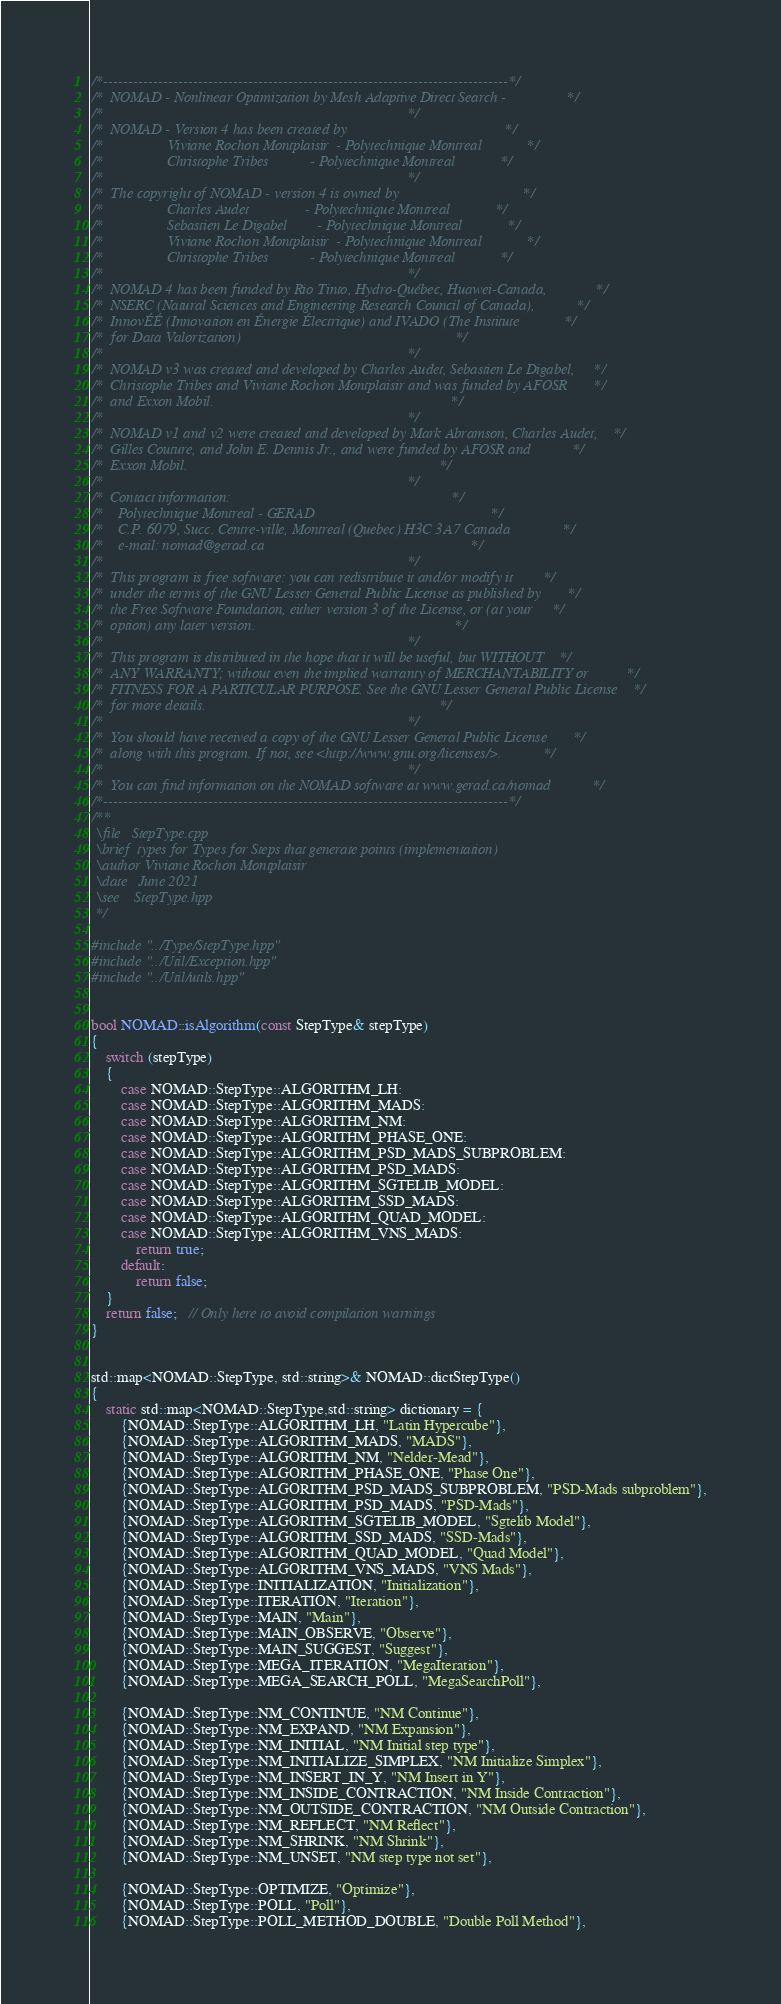Convert code to text. <code><loc_0><loc_0><loc_500><loc_500><_C++_>/*---------------------------------------------------------------------------------*/
/*  NOMAD - Nonlinear Optimization by Mesh Adaptive Direct Search -                */
/*                                                                                 */
/*  NOMAD - Version 4 has been created by                                          */
/*                 Viviane Rochon Montplaisir  - Polytechnique Montreal            */
/*                 Christophe Tribes           - Polytechnique Montreal            */
/*                                                                                 */
/*  The copyright of NOMAD - version 4 is owned by                                 */
/*                 Charles Audet               - Polytechnique Montreal            */
/*                 Sebastien Le Digabel        - Polytechnique Montreal            */
/*                 Viviane Rochon Montplaisir  - Polytechnique Montreal            */
/*                 Christophe Tribes           - Polytechnique Montreal            */
/*                                                                                 */
/*  NOMAD 4 has been funded by Rio Tinto, Hydro-Québec, Huawei-Canada,             */
/*  NSERC (Natural Sciences and Engineering Research Council of Canada),           */
/*  InnovÉÉ (Innovation en Énergie Électrique) and IVADO (The Institute            */
/*  for Data Valorization)                                                         */
/*                                                                                 */
/*  NOMAD v3 was created and developed by Charles Audet, Sebastien Le Digabel,     */
/*  Christophe Tribes and Viviane Rochon Montplaisir and was funded by AFOSR       */
/*  and Exxon Mobil.                                                               */
/*                                                                                 */
/*  NOMAD v1 and v2 were created and developed by Mark Abramson, Charles Audet,    */
/*  Gilles Couture, and John E. Dennis Jr., and were funded by AFOSR and           */
/*  Exxon Mobil.                                                                   */
/*                                                                                 */
/*  Contact information:                                                           */
/*    Polytechnique Montreal - GERAD                                               */
/*    C.P. 6079, Succ. Centre-ville, Montreal (Quebec) H3C 3A7 Canada              */
/*    e-mail: nomad@gerad.ca                                                       */
/*                                                                                 */
/*  This program is free software: you can redistribute it and/or modify it        */
/*  under the terms of the GNU Lesser General Public License as published by       */
/*  the Free Software Foundation, either version 3 of the License, or (at your     */
/*  option) any later version.                                                     */
/*                                                                                 */
/*  This program is distributed in the hope that it will be useful, but WITHOUT    */
/*  ANY WARRANTY; without even the implied warranty of MERCHANTABILITY or          */
/*  FITNESS FOR A PARTICULAR PURPOSE. See the GNU Lesser General Public License    */
/*  for more details.                                                              */
/*                                                                                 */
/*  You should have received a copy of the GNU Lesser General Public License       */
/*  along with this program. If not, see <http://www.gnu.org/licenses/>.           */
/*                                                                                 */
/*  You can find information on the NOMAD software at www.gerad.ca/nomad           */
/*---------------------------------------------------------------------------------*/
/**
 \file   StepType.cpp
 \brief  types for Types for Steps that generate points (implementation)
 \author Viviane Rochon Montplaisir
 \date   June 2021
 \see    StepType.hpp
 */

#include "../Type/StepType.hpp"
#include "../Util/Exception.hpp"
#include "../Util/utils.hpp"


bool NOMAD::isAlgorithm(const StepType& stepType)
{
    switch (stepType)
    {
        case NOMAD::StepType::ALGORITHM_LH:
        case NOMAD::StepType::ALGORITHM_MADS:
        case NOMAD::StepType::ALGORITHM_NM:
        case NOMAD::StepType::ALGORITHM_PHASE_ONE:
        case NOMAD::StepType::ALGORITHM_PSD_MADS_SUBPROBLEM:
        case NOMAD::StepType::ALGORITHM_PSD_MADS:
        case NOMAD::StepType::ALGORITHM_SGTELIB_MODEL:
        case NOMAD::StepType::ALGORITHM_SSD_MADS:
        case NOMAD::StepType::ALGORITHM_QUAD_MODEL:
        case NOMAD::StepType::ALGORITHM_VNS_MADS:
            return true;
        default:
            return false;
    }
    return false;   // Only here to avoid compilation warnings
}


std::map<NOMAD::StepType, std::string>& NOMAD::dictStepType()
{
    static std::map<NOMAD::StepType,std::string> dictionary = {
        {NOMAD::StepType::ALGORITHM_LH, "Latin Hypercube"},
        {NOMAD::StepType::ALGORITHM_MADS, "MADS"},
        {NOMAD::StepType::ALGORITHM_NM, "Nelder-Mead"},
        {NOMAD::StepType::ALGORITHM_PHASE_ONE, "Phase One"},
        {NOMAD::StepType::ALGORITHM_PSD_MADS_SUBPROBLEM, "PSD-Mads subproblem"},
        {NOMAD::StepType::ALGORITHM_PSD_MADS, "PSD-Mads"},
        {NOMAD::StepType::ALGORITHM_SGTELIB_MODEL, "Sgtelib Model"},
        {NOMAD::StepType::ALGORITHM_SSD_MADS, "SSD-Mads"},
        {NOMAD::StepType::ALGORITHM_QUAD_MODEL, "Quad Model"},
        {NOMAD::StepType::ALGORITHM_VNS_MADS, "VNS Mads"},
        {NOMAD::StepType::INITIALIZATION, "Initialization"},
        {NOMAD::StepType::ITERATION, "Iteration"},
        {NOMAD::StepType::MAIN, "Main"},
        {NOMAD::StepType::MAIN_OBSERVE, "Observe"},
        {NOMAD::StepType::MAIN_SUGGEST, "Suggest"},
        {NOMAD::StepType::MEGA_ITERATION, "MegaIteration"},
        {NOMAD::StepType::MEGA_SEARCH_POLL, "MegaSearchPoll"},

        {NOMAD::StepType::NM_CONTINUE, "NM Continue"},
        {NOMAD::StepType::NM_EXPAND, "NM Expansion"},
        {NOMAD::StepType::NM_INITIAL, "NM Initial step type"},
        {NOMAD::StepType::NM_INITIALIZE_SIMPLEX, "NM Initialize Simplex"},
        {NOMAD::StepType::NM_INSERT_IN_Y, "NM Insert in Y"},
        {NOMAD::StepType::NM_INSIDE_CONTRACTION, "NM Inside Contraction"},
        {NOMAD::StepType::NM_OUTSIDE_CONTRACTION, "NM Outside Contraction"},
        {NOMAD::StepType::NM_REFLECT, "NM Reflect"},
        {NOMAD::StepType::NM_SHRINK, "NM Shrink"},
        {NOMAD::StepType::NM_UNSET, "NM step type not set"},

        {NOMAD::StepType::OPTIMIZE, "Optimize"},
        {NOMAD::StepType::POLL, "Poll"},
        {NOMAD::StepType::POLL_METHOD_DOUBLE, "Double Poll Method"},</code> 